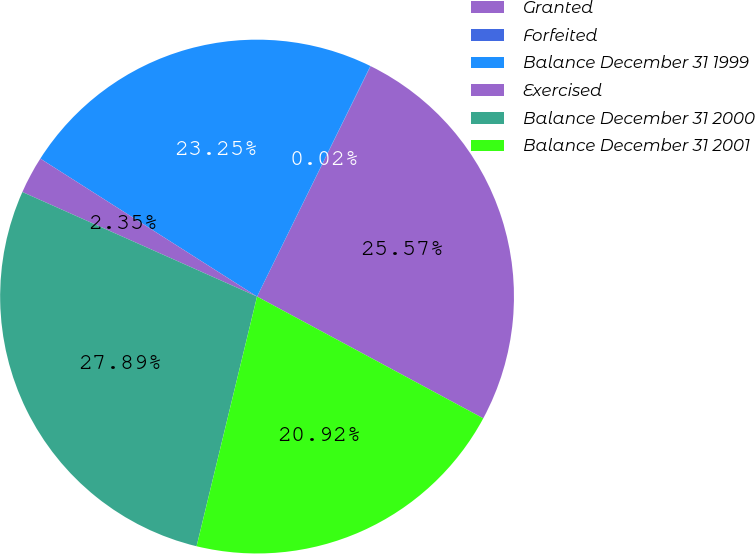Convert chart. <chart><loc_0><loc_0><loc_500><loc_500><pie_chart><fcel>Granted<fcel>Forfeited<fcel>Balance December 31 1999<fcel>Exercised<fcel>Balance December 31 2000<fcel>Balance December 31 2001<nl><fcel>25.57%<fcel>0.02%<fcel>23.25%<fcel>2.35%<fcel>27.89%<fcel>20.92%<nl></chart> 